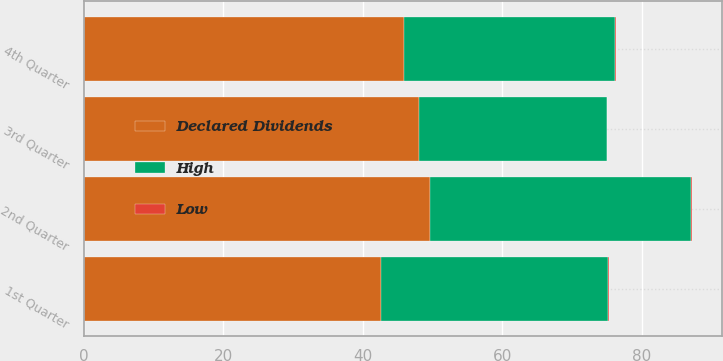Convert chart. <chart><loc_0><loc_0><loc_500><loc_500><stacked_bar_chart><ecel><fcel>1st Quarter<fcel>2nd Quarter<fcel>3rd Quarter<fcel>4th Quarter<nl><fcel>Declared Dividends<fcel>42.63<fcel>49.57<fcel>48.01<fcel>45.94<nl><fcel>High<fcel>32.62<fcel>37.56<fcel>27<fcel>30.28<nl><fcel>Low<fcel>0.04<fcel>0.04<fcel>0.04<fcel>0.04<nl></chart> 